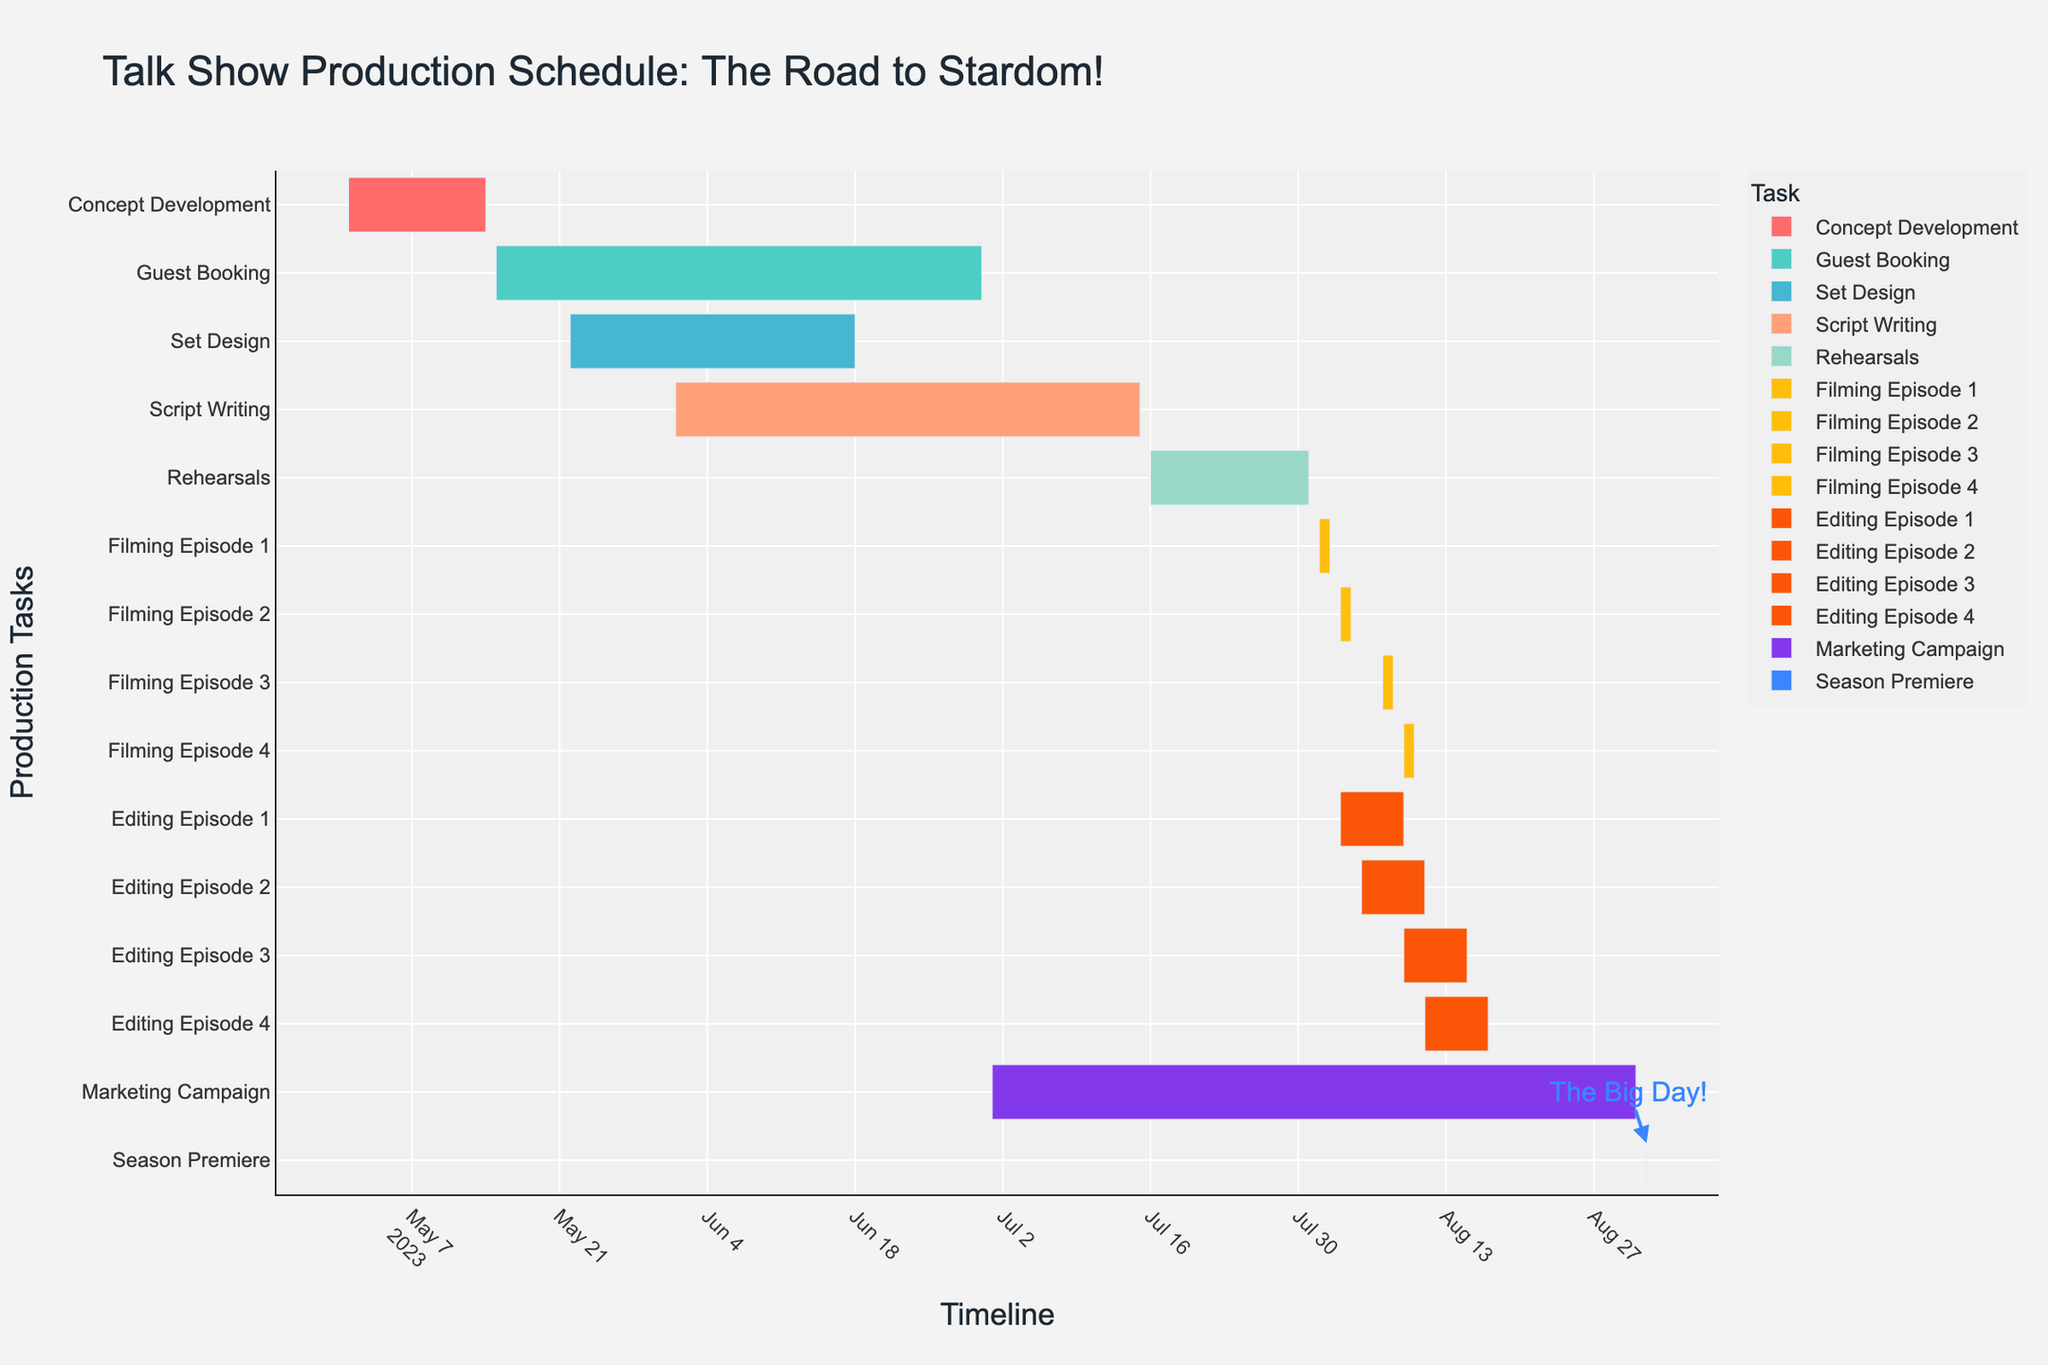What is the title of the chart? The title of the chart is located at the top and is the largest text in the figure.
Answer: Talk Show Production Schedule: The Road to Stardom! Which task starts the earliest in the production schedule? The earliest start date is at the beginning of the timeline. "Concept Development" starts on May 1, 2023.
Answer: Concept Development How long does the "Script Writing" stage last? To find the duration, subtract the start date from the end date for the "Script Writing" task. The task starts on June 1, 2023, and ends on July 15, 2023, which is 45 days.
Answer: 45 days Which task has the shortest duration? Look for the task with the smallest span on the timeline. "Filming Episode 1" and other filming tasks each last for 2 days, the shortest among all tasks.
Answer: Filming Episode 1 (or any filming task) Identify two tasks that overlap in July 2023? Check for tasks that appear on the timeline for July 2023 with overlapping time frames. "Script Writing" (June 1 - July 15) and "Rehearsals" (July 16 - July 31) overlap in July.
Answer: Script Writing and Rehearsals What is the total duration from the start of "Concept Development" to the "Season Premiere"? Calculate the number of days from the start of "Concept Development" (May 1, 2023) to the "Season Premiere" (September 1, 2023). The period is 124 days.
Answer: 124 days Which stage directly follows the "Rehearsals"? Identify the next task on the timeline after "Rehearsals" ends on July 31, 2023. "Filming Episode 1" starts on August 1, 2023.
Answer: Filming Episode 1 How many tasks are involved in the filming stage? Count the number of tasks related to filming as shown on the timeline. There are four tasks: Filming Episode 1, Filming Episode 2, Filming Episode 3, and Filming Episode 4.
Answer: 4 Between "Set Design" and "Guest Booking," which one ends earlier? Compare the end dates of both tasks. "Set Design" ends on June 18, 2023 and "Guest Booking" ends on June 30, 2023.
Answer: Set Design Are there any tasks that start and end on the same day? Look for any task with the same start and end date. The "Season Premiere" is shown to both start and end on September 1, 2023.
Answer: Season Premiere What is the duration of tasks in the "Editing" stage combined? Sum up the duration of all editing tasks: Editing Episode 1 (7 days), Editing Episode 2 (7 days), Editing Episode 3 (6 days), and Editing Episode 4 (6 days). The total is 26 days.
Answer: 26 days 